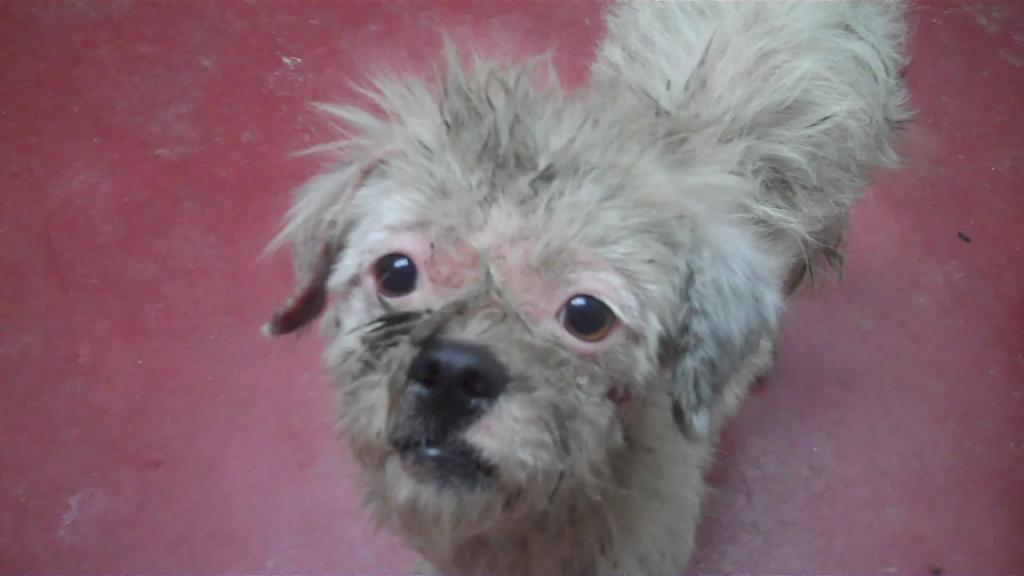What is the main subject of the image? There is a dog in the center of the image. What type of word is being used by the dog in the image? There is no word being used by the dog in the image, as dogs do not use words like humans do. 